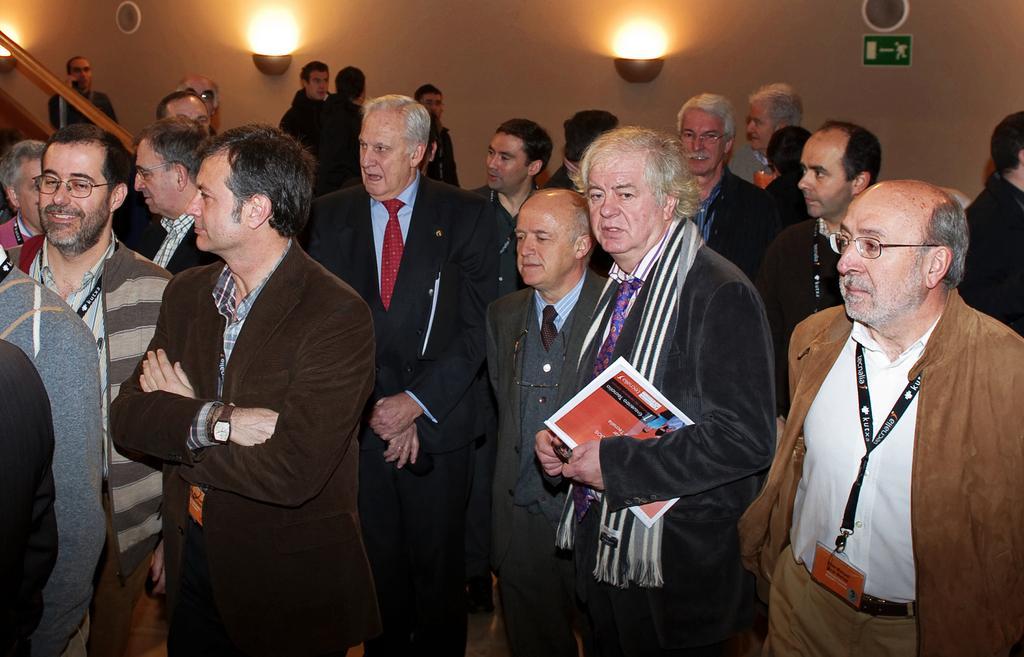In one or two sentences, can you explain what this image depicts? In the picture we can see a few men are standing in a blazer, and one man is holding a book and in the background we can see the wall with two lights. 